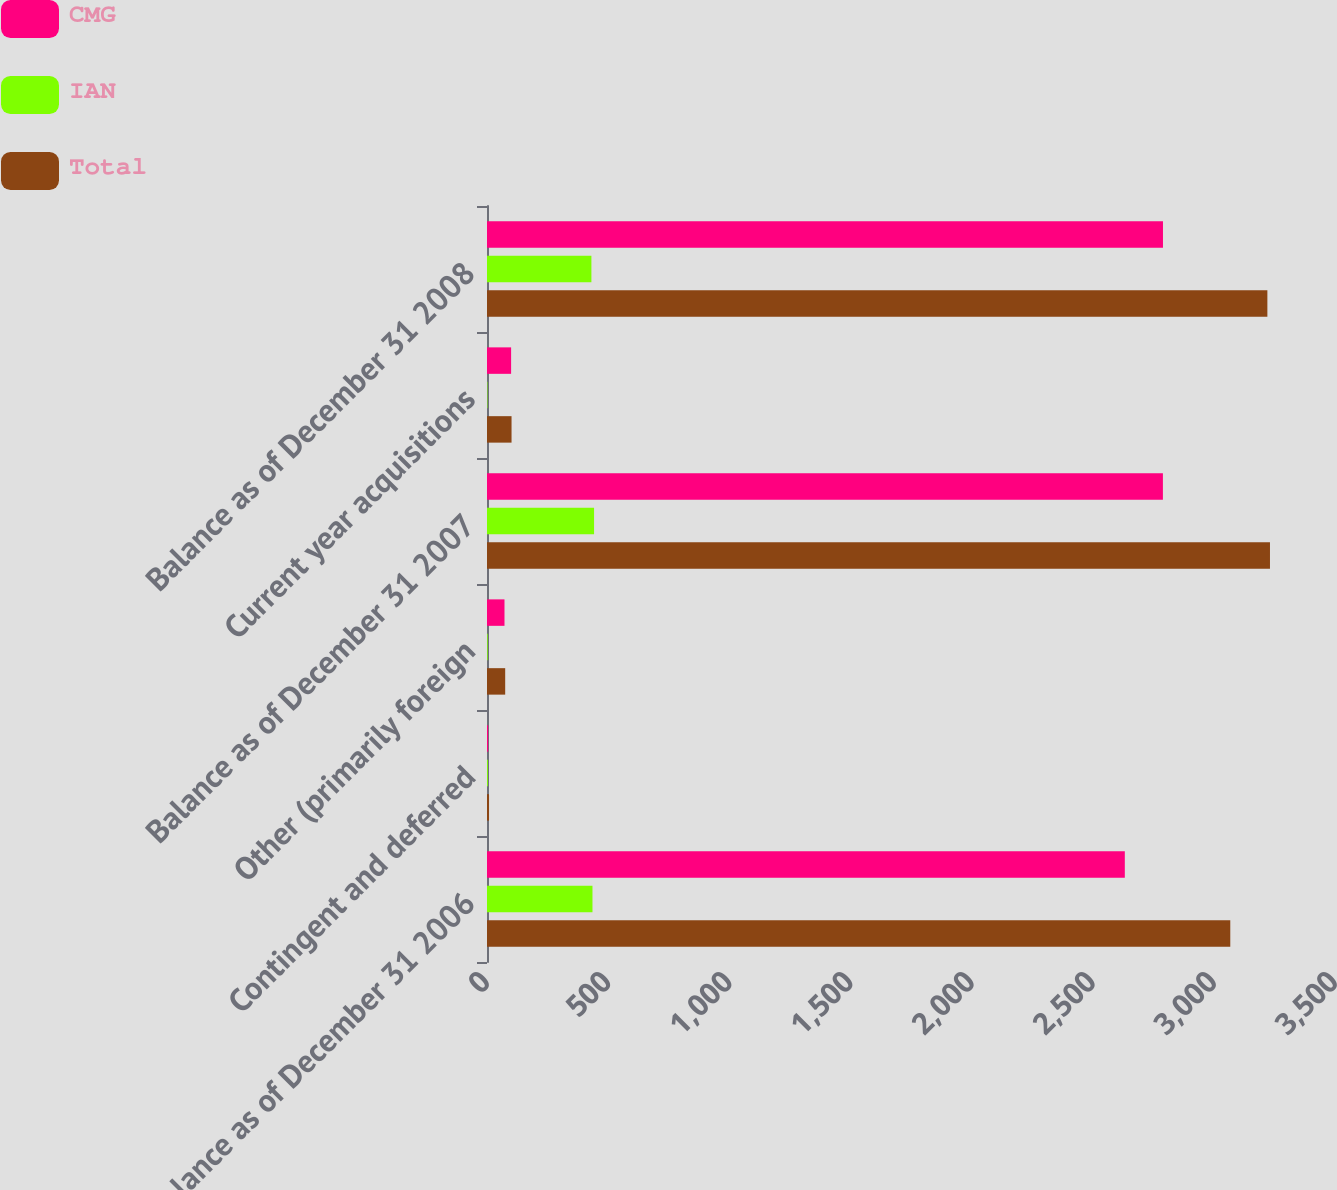<chart> <loc_0><loc_0><loc_500><loc_500><stacked_bar_chart><ecel><fcel>Balance as of December 31 2006<fcel>Contingent and deferred<fcel>Other (primarily foreign<fcel>Balance as of December 31 2007<fcel>Current year acquisitions<fcel>Balance as of December 31 2008<nl><fcel>CMG<fcel>2632.5<fcel>4.7<fcel>72.2<fcel>2789.7<fcel>99.5<fcel>2790<nl><fcel>IAN<fcel>435.3<fcel>3.7<fcel>2.9<fcel>441.9<fcel>1.8<fcel>430.9<nl><fcel>Total<fcel>3067.8<fcel>8.4<fcel>75.1<fcel>3231.6<fcel>101.3<fcel>3220.9<nl></chart> 